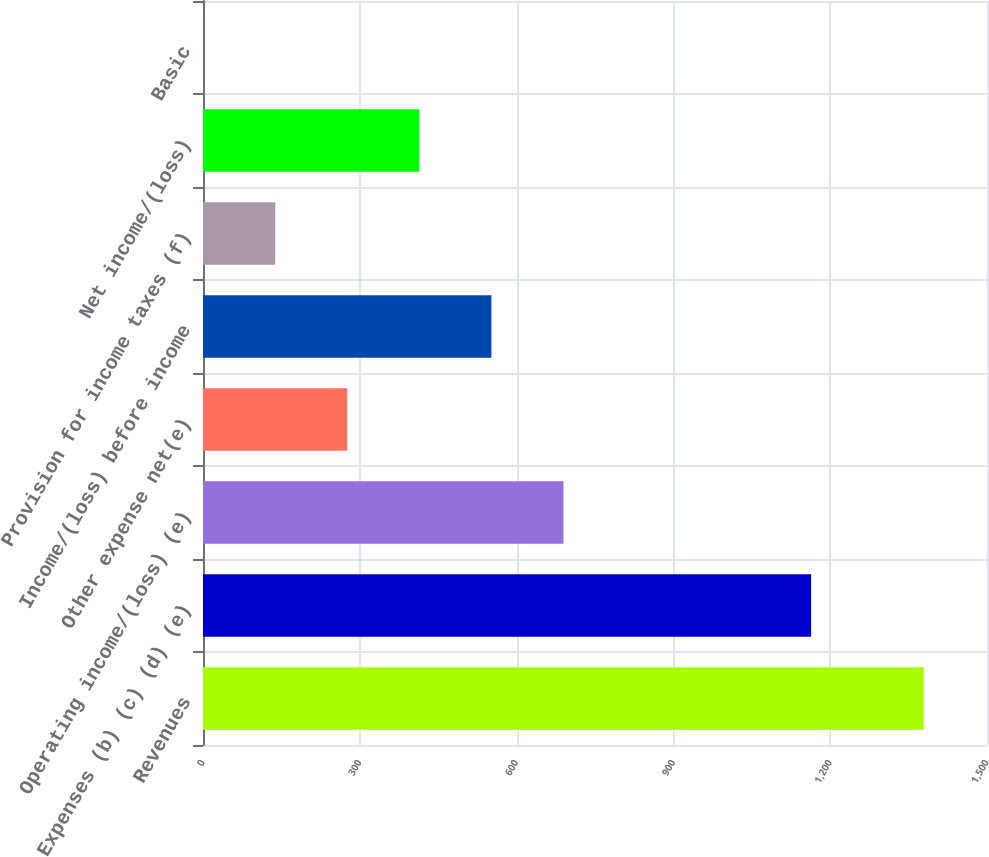<chart> <loc_0><loc_0><loc_500><loc_500><bar_chart><fcel>Revenues<fcel>Expenses (b) (c) (d) (e)<fcel>Operating income/(loss) (e)<fcel>Other expense net(e)<fcel>Income/(loss) before income<fcel>Provision for income taxes (f)<fcel>Net income/(loss)<fcel>Basic<nl><fcel>1378.9<fcel>1163.5<fcel>689.64<fcel>276.07<fcel>551.79<fcel>138.21<fcel>413.93<fcel>0.35<nl></chart> 